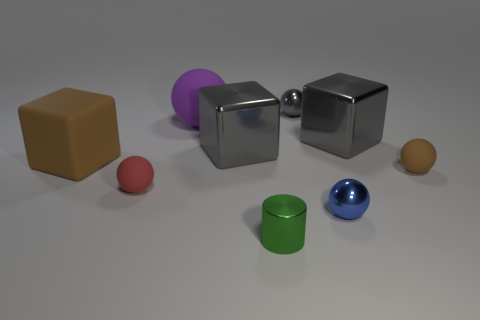Can you describe the lighting in the scene? The scene is softly lit from above, casting gentle shadows beneath the objects, highlighting their shapes without creating harsh contrasts. 